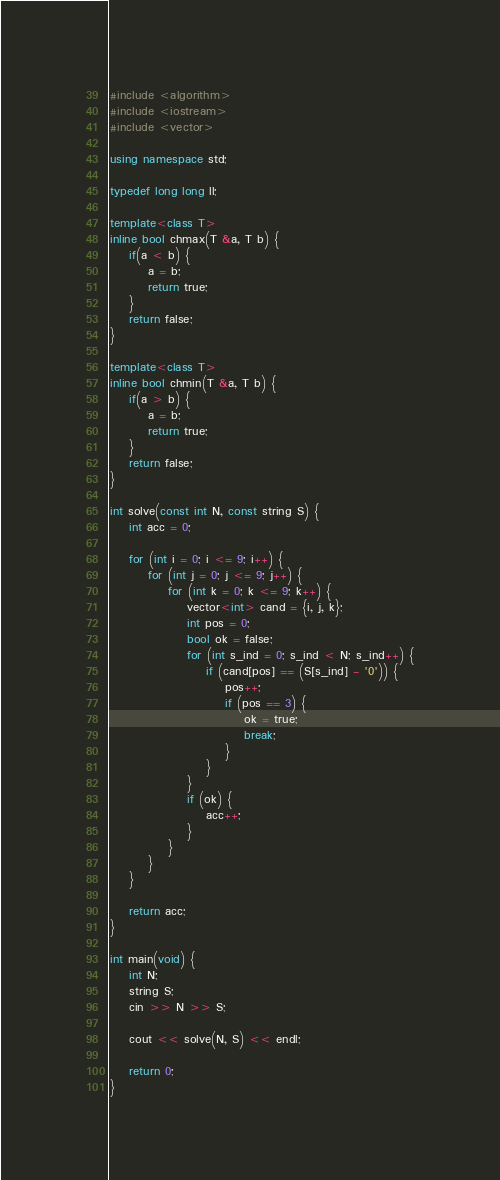Convert code to text. <code><loc_0><loc_0><loc_500><loc_500><_C++_>#include <algorithm>
#include <iostream>
#include <vector>

using namespace std;

typedef long long ll;

template<class T>
inline bool chmax(T &a, T b) {
    if(a < b) {
        a = b;
        return true;
    }
    return false;
}

template<class T>
inline bool chmin(T &a, T b) {
    if(a > b) {
        a = b;
        return true;
    }
    return false;
}

int solve(const int N, const string S) {
    int acc = 0;

    for (int i = 0; i <= 9; i++) {
        for (int j = 0; j <= 9; j++) {
            for (int k = 0; k <= 9; k++) {
                vector<int> cand = {i, j, k};
                int pos = 0;
                bool ok = false;
                for (int s_ind = 0; s_ind < N; s_ind++) {
                    if (cand[pos] == (S[s_ind] - '0')) {
                        pos++;
                        if (pos == 3) {
                            ok = true;
                            break;
                        }
                    }
                }
                if (ok) {
                    acc++;
                }
            }
        }
    }

    return acc;
}

int main(void) {
    int N;
    string S;
    cin >> N >> S;

    cout << solve(N, S) << endl;

    return 0;
}
</code> 